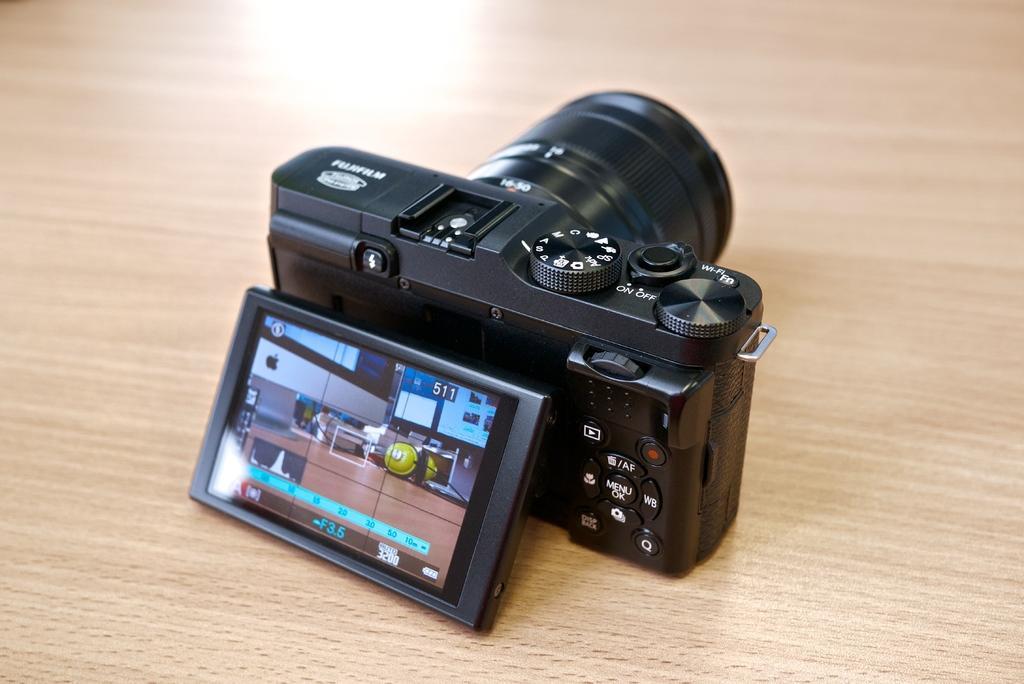Please provide a concise description of this image. In this image I can see a black colour camera and here I can see a screen. I can also see something is written at many places. 